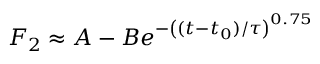<formula> <loc_0><loc_0><loc_500><loc_500>F _ { 2 } \approx A - B e ^ { - \left ( ( t - t _ { 0 } ) / \tau \right ) ^ { 0 . 7 5 } }</formula> 